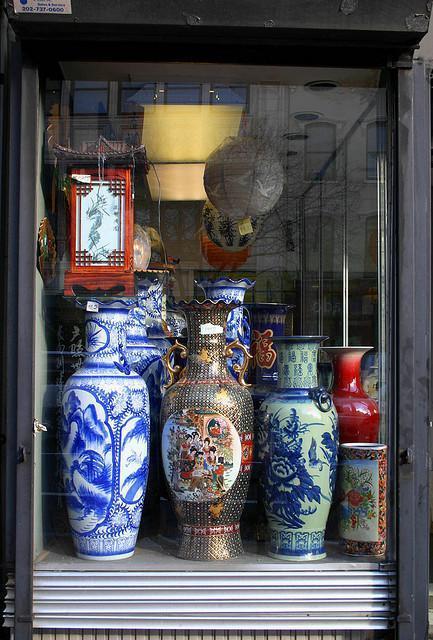How many windows do you see?
Give a very brief answer. 1. How many vases are there?
Give a very brief answer. 7. How many giraffes are shorter that the lamp post?
Give a very brief answer. 0. 